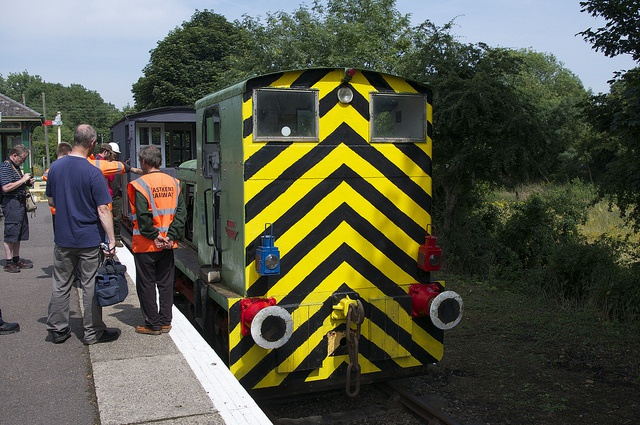Describe the objects in this image and their specific colors. I can see train in lavender, black, gold, gray, and olive tones, people in lavender, gray, black, navy, and darkblue tones, people in lavender, black, gray, salmon, and brown tones, people in lavender, black, and gray tones, and handbag in lavender, black, gray, and darkblue tones in this image. 